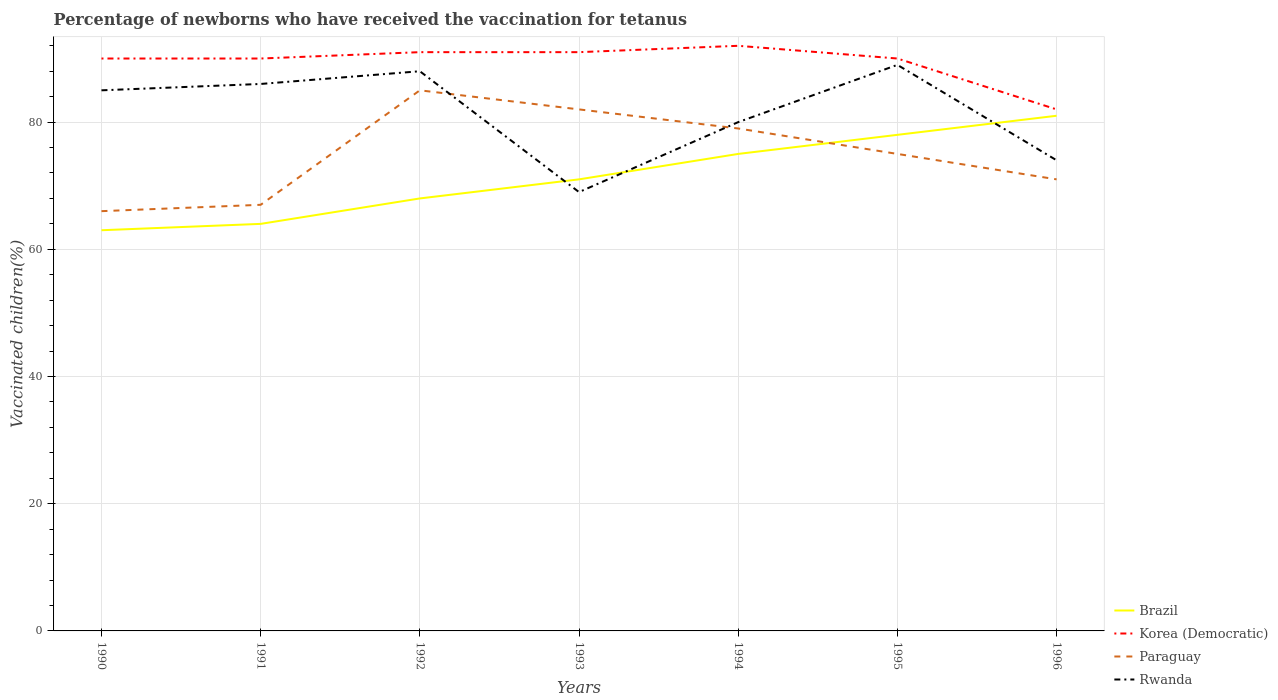Does the line corresponding to Paraguay intersect with the line corresponding to Rwanda?
Offer a very short reply. Yes. In which year was the percentage of vaccinated children in Korea (Democratic) maximum?
Keep it short and to the point. 1996. What is the difference between the highest and the lowest percentage of vaccinated children in Paraguay?
Keep it short and to the point. 3. Is the percentage of vaccinated children in Korea (Democratic) strictly greater than the percentage of vaccinated children in Brazil over the years?
Provide a short and direct response. No. Are the values on the major ticks of Y-axis written in scientific E-notation?
Offer a very short reply. No. Where does the legend appear in the graph?
Your answer should be compact. Bottom right. What is the title of the graph?
Keep it short and to the point. Percentage of newborns who have received the vaccination for tetanus. What is the label or title of the X-axis?
Make the answer very short. Years. What is the label or title of the Y-axis?
Offer a terse response. Vaccinated children(%). What is the Vaccinated children(%) of Korea (Democratic) in 1990?
Give a very brief answer. 90. What is the Vaccinated children(%) of Paraguay in 1990?
Keep it short and to the point. 66. What is the Vaccinated children(%) in Rwanda in 1990?
Keep it short and to the point. 85. What is the Vaccinated children(%) of Paraguay in 1991?
Offer a very short reply. 67. What is the Vaccinated children(%) in Korea (Democratic) in 1992?
Your answer should be very brief. 91. What is the Vaccinated children(%) in Rwanda in 1992?
Your answer should be compact. 88. What is the Vaccinated children(%) of Brazil in 1993?
Ensure brevity in your answer.  71. What is the Vaccinated children(%) of Korea (Democratic) in 1993?
Your answer should be compact. 91. What is the Vaccinated children(%) in Paraguay in 1993?
Offer a very short reply. 82. What is the Vaccinated children(%) in Korea (Democratic) in 1994?
Your answer should be compact. 92. What is the Vaccinated children(%) in Paraguay in 1994?
Your answer should be compact. 79. What is the Vaccinated children(%) in Brazil in 1995?
Your answer should be very brief. 78. What is the Vaccinated children(%) of Rwanda in 1995?
Provide a short and direct response. 89. What is the Vaccinated children(%) in Paraguay in 1996?
Your response must be concise. 71. What is the Vaccinated children(%) in Rwanda in 1996?
Offer a very short reply. 74. Across all years, what is the maximum Vaccinated children(%) of Brazil?
Offer a very short reply. 81. Across all years, what is the maximum Vaccinated children(%) in Korea (Democratic)?
Provide a succinct answer. 92. Across all years, what is the maximum Vaccinated children(%) of Rwanda?
Provide a short and direct response. 89. Across all years, what is the minimum Vaccinated children(%) in Brazil?
Keep it short and to the point. 63. Across all years, what is the minimum Vaccinated children(%) in Paraguay?
Give a very brief answer. 66. What is the total Vaccinated children(%) in Korea (Democratic) in the graph?
Give a very brief answer. 626. What is the total Vaccinated children(%) in Paraguay in the graph?
Your answer should be compact. 525. What is the total Vaccinated children(%) in Rwanda in the graph?
Ensure brevity in your answer.  571. What is the difference between the Vaccinated children(%) of Brazil in 1990 and that in 1991?
Offer a very short reply. -1. What is the difference between the Vaccinated children(%) in Paraguay in 1990 and that in 1992?
Provide a short and direct response. -19. What is the difference between the Vaccinated children(%) of Brazil in 1990 and that in 1993?
Ensure brevity in your answer.  -8. What is the difference between the Vaccinated children(%) in Paraguay in 1990 and that in 1993?
Offer a terse response. -16. What is the difference between the Vaccinated children(%) in Brazil in 1990 and that in 1994?
Make the answer very short. -12. What is the difference between the Vaccinated children(%) in Korea (Democratic) in 1990 and that in 1994?
Offer a terse response. -2. What is the difference between the Vaccinated children(%) in Rwanda in 1990 and that in 1994?
Offer a very short reply. 5. What is the difference between the Vaccinated children(%) in Brazil in 1990 and that in 1995?
Make the answer very short. -15. What is the difference between the Vaccinated children(%) in Paraguay in 1990 and that in 1995?
Offer a terse response. -9. What is the difference between the Vaccinated children(%) in Rwanda in 1990 and that in 1995?
Your answer should be compact. -4. What is the difference between the Vaccinated children(%) in Brazil in 1990 and that in 1996?
Ensure brevity in your answer.  -18. What is the difference between the Vaccinated children(%) of Korea (Democratic) in 1990 and that in 1996?
Provide a succinct answer. 8. What is the difference between the Vaccinated children(%) of Rwanda in 1990 and that in 1996?
Keep it short and to the point. 11. What is the difference between the Vaccinated children(%) in Brazil in 1991 and that in 1992?
Make the answer very short. -4. What is the difference between the Vaccinated children(%) in Brazil in 1991 and that in 1993?
Provide a short and direct response. -7. What is the difference between the Vaccinated children(%) in Brazil in 1991 and that in 1994?
Provide a short and direct response. -11. What is the difference between the Vaccinated children(%) in Korea (Democratic) in 1991 and that in 1994?
Ensure brevity in your answer.  -2. What is the difference between the Vaccinated children(%) in Paraguay in 1991 and that in 1995?
Your response must be concise. -8. What is the difference between the Vaccinated children(%) of Rwanda in 1991 and that in 1995?
Make the answer very short. -3. What is the difference between the Vaccinated children(%) of Korea (Democratic) in 1991 and that in 1996?
Give a very brief answer. 8. What is the difference between the Vaccinated children(%) of Korea (Democratic) in 1992 and that in 1993?
Provide a short and direct response. 0. What is the difference between the Vaccinated children(%) of Rwanda in 1992 and that in 1993?
Your answer should be compact. 19. What is the difference between the Vaccinated children(%) in Korea (Democratic) in 1992 and that in 1994?
Keep it short and to the point. -1. What is the difference between the Vaccinated children(%) of Paraguay in 1992 and that in 1994?
Provide a succinct answer. 6. What is the difference between the Vaccinated children(%) in Rwanda in 1992 and that in 1994?
Your answer should be compact. 8. What is the difference between the Vaccinated children(%) of Brazil in 1992 and that in 1995?
Your answer should be very brief. -10. What is the difference between the Vaccinated children(%) of Paraguay in 1992 and that in 1995?
Your answer should be compact. 10. What is the difference between the Vaccinated children(%) in Brazil in 1992 and that in 1996?
Give a very brief answer. -13. What is the difference between the Vaccinated children(%) of Korea (Democratic) in 1992 and that in 1996?
Give a very brief answer. 9. What is the difference between the Vaccinated children(%) of Brazil in 1993 and that in 1994?
Make the answer very short. -4. What is the difference between the Vaccinated children(%) in Paraguay in 1993 and that in 1994?
Give a very brief answer. 3. What is the difference between the Vaccinated children(%) of Rwanda in 1993 and that in 1994?
Provide a short and direct response. -11. What is the difference between the Vaccinated children(%) in Brazil in 1993 and that in 1995?
Provide a succinct answer. -7. What is the difference between the Vaccinated children(%) in Korea (Democratic) in 1993 and that in 1995?
Make the answer very short. 1. What is the difference between the Vaccinated children(%) in Korea (Democratic) in 1993 and that in 1996?
Provide a short and direct response. 9. What is the difference between the Vaccinated children(%) in Rwanda in 1993 and that in 1996?
Your answer should be compact. -5. What is the difference between the Vaccinated children(%) of Brazil in 1994 and that in 1995?
Provide a short and direct response. -3. What is the difference between the Vaccinated children(%) in Rwanda in 1994 and that in 1995?
Provide a short and direct response. -9. What is the difference between the Vaccinated children(%) of Korea (Democratic) in 1994 and that in 1996?
Your answer should be very brief. 10. What is the difference between the Vaccinated children(%) in Rwanda in 1994 and that in 1996?
Give a very brief answer. 6. What is the difference between the Vaccinated children(%) in Korea (Democratic) in 1995 and that in 1996?
Your answer should be compact. 8. What is the difference between the Vaccinated children(%) in Brazil in 1990 and the Vaccinated children(%) in Korea (Democratic) in 1991?
Your response must be concise. -27. What is the difference between the Vaccinated children(%) of Brazil in 1990 and the Vaccinated children(%) of Paraguay in 1991?
Offer a very short reply. -4. What is the difference between the Vaccinated children(%) in Brazil in 1990 and the Vaccinated children(%) in Rwanda in 1991?
Offer a terse response. -23. What is the difference between the Vaccinated children(%) in Brazil in 1990 and the Vaccinated children(%) in Korea (Democratic) in 1992?
Give a very brief answer. -28. What is the difference between the Vaccinated children(%) in Brazil in 1990 and the Vaccinated children(%) in Rwanda in 1992?
Give a very brief answer. -25. What is the difference between the Vaccinated children(%) of Korea (Democratic) in 1990 and the Vaccinated children(%) of Paraguay in 1992?
Offer a terse response. 5. What is the difference between the Vaccinated children(%) in Korea (Democratic) in 1990 and the Vaccinated children(%) in Rwanda in 1992?
Provide a short and direct response. 2. What is the difference between the Vaccinated children(%) in Paraguay in 1990 and the Vaccinated children(%) in Rwanda in 1992?
Your answer should be very brief. -22. What is the difference between the Vaccinated children(%) of Brazil in 1990 and the Vaccinated children(%) of Paraguay in 1993?
Provide a short and direct response. -19. What is the difference between the Vaccinated children(%) of Brazil in 1990 and the Vaccinated children(%) of Korea (Democratic) in 1994?
Ensure brevity in your answer.  -29. What is the difference between the Vaccinated children(%) of Korea (Democratic) in 1990 and the Vaccinated children(%) of Rwanda in 1994?
Your response must be concise. 10. What is the difference between the Vaccinated children(%) of Paraguay in 1990 and the Vaccinated children(%) of Rwanda in 1994?
Provide a short and direct response. -14. What is the difference between the Vaccinated children(%) in Brazil in 1990 and the Vaccinated children(%) in Paraguay in 1995?
Offer a terse response. -12. What is the difference between the Vaccinated children(%) of Brazil in 1990 and the Vaccinated children(%) of Rwanda in 1995?
Keep it short and to the point. -26. What is the difference between the Vaccinated children(%) in Korea (Democratic) in 1990 and the Vaccinated children(%) in Rwanda in 1995?
Offer a very short reply. 1. What is the difference between the Vaccinated children(%) in Brazil in 1990 and the Vaccinated children(%) in Korea (Democratic) in 1996?
Provide a short and direct response. -19. What is the difference between the Vaccinated children(%) of Brazil in 1990 and the Vaccinated children(%) of Paraguay in 1996?
Give a very brief answer. -8. What is the difference between the Vaccinated children(%) of Brazil in 1990 and the Vaccinated children(%) of Rwanda in 1996?
Provide a short and direct response. -11. What is the difference between the Vaccinated children(%) of Korea (Democratic) in 1990 and the Vaccinated children(%) of Rwanda in 1996?
Your response must be concise. 16. What is the difference between the Vaccinated children(%) in Paraguay in 1990 and the Vaccinated children(%) in Rwanda in 1996?
Provide a short and direct response. -8. What is the difference between the Vaccinated children(%) of Brazil in 1991 and the Vaccinated children(%) of Korea (Democratic) in 1992?
Offer a very short reply. -27. What is the difference between the Vaccinated children(%) of Brazil in 1991 and the Vaccinated children(%) of Paraguay in 1993?
Your answer should be very brief. -18. What is the difference between the Vaccinated children(%) in Korea (Democratic) in 1991 and the Vaccinated children(%) in Paraguay in 1993?
Offer a very short reply. 8. What is the difference between the Vaccinated children(%) in Korea (Democratic) in 1991 and the Vaccinated children(%) in Rwanda in 1993?
Offer a terse response. 21. What is the difference between the Vaccinated children(%) of Brazil in 1991 and the Vaccinated children(%) of Paraguay in 1994?
Give a very brief answer. -15. What is the difference between the Vaccinated children(%) of Brazil in 1991 and the Vaccinated children(%) of Rwanda in 1994?
Offer a terse response. -16. What is the difference between the Vaccinated children(%) in Paraguay in 1991 and the Vaccinated children(%) in Rwanda in 1994?
Keep it short and to the point. -13. What is the difference between the Vaccinated children(%) of Brazil in 1991 and the Vaccinated children(%) of Korea (Democratic) in 1995?
Give a very brief answer. -26. What is the difference between the Vaccinated children(%) in Brazil in 1991 and the Vaccinated children(%) in Paraguay in 1995?
Offer a very short reply. -11. What is the difference between the Vaccinated children(%) in Korea (Democratic) in 1991 and the Vaccinated children(%) in Paraguay in 1995?
Your answer should be compact. 15. What is the difference between the Vaccinated children(%) of Paraguay in 1991 and the Vaccinated children(%) of Rwanda in 1995?
Provide a short and direct response. -22. What is the difference between the Vaccinated children(%) of Brazil in 1991 and the Vaccinated children(%) of Korea (Democratic) in 1996?
Keep it short and to the point. -18. What is the difference between the Vaccinated children(%) in Brazil in 1991 and the Vaccinated children(%) in Paraguay in 1996?
Your answer should be compact. -7. What is the difference between the Vaccinated children(%) of Brazil in 1991 and the Vaccinated children(%) of Rwanda in 1996?
Your answer should be compact. -10. What is the difference between the Vaccinated children(%) in Korea (Democratic) in 1991 and the Vaccinated children(%) in Paraguay in 1996?
Keep it short and to the point. 19. What is the difference between the Vaccinated children(%) in Korea (Democratic) in 1991 and the Vaccinated children(%) in Rwanda in 1996?
Give a very brief answer. 16. What is the difference between the Vaccinated children(%) in Paraguay in 1991 and the Vaccinated children(%) in Rwanda in 1996?
Keep it short and to the point. -7. What is the difference between the Vaccinated children(%) in Brazil in 1992 and the Vaccinated children(%) in Korea (Democratic) in 1993?
Ensure brevity in your answer.  -23. What is the difference between the Vaccinated children(%) in Brazil in 1992 and the Vaccinated children(%) in Paraguay in 1993?
Provide a succinct answer. -14. What is the difference between the Vaccinated children(%) of Paraguay in 1992 and the Vaccinated children(%) of Rwanda in 1993?
Provide a succinct answer. 16. What is the difference between the Vaccinated children(%) in Brazil in 1992 and the Vaccinated children(%) in Paraguay in 1994?
Provide a short and direct response. -11. What is the difference between the Vaccinated children(%) of Korea (Democratic) in 1992 and the Vaccinated children(%) of Paraguay in 1994?
Offer a terse response. 12. What is the difference between the Vaccinated children(%) in Korea (Democratic) in 1992 and the Vaccinated children(%) in Rwanda in 1994?
Make the answer very short. 11. What is the difference between the Vaccinated children(%) of Brazil in 1992 and the Vaccinated children(%) of Korea (Democratic) in 1995?
Keep it short and to the point. -22. What is the difference between the Vaccinated children(%) in Korea (Democratic) in 1992 and the Vaccinated children(%) in Paraguay in 1995?
Keep it short and to the point. 16. What is the difference between the Vaccinated children(%) in Paraguay in 1992 and the Vaccinated children(%) in Rwanda in 1995?
Offer a very short reply. -4. What is the difference between the Vaccinated children(%) of Brazil in 1992 and the Vaccinated children(%) of Korea (Democratic) in 1996?
Offer a terse response. -14. What is the difference between the Vaccinated children(%) of Brazil in 1992 and the Vaccinated children(%) of Paraguay in 1996?
Keep it short and to the point. -3. What is the difference between the Vaccinated children(%) in Brazil in 1992 and the Vaccinated children(%) in Rwanda in 1996?
Offer a terse response. -6. What is the difference between the Vaccinated children(%) in Korea (Democratic) in 1992 and the Vaccinated children(%) in Rwanda in 1996?
Provide a succinct answer. 17. What is the difference between the Vaccinated children(%) of Paraguay in 1992 and the Vaccinated children(%) of Rwanda in 1996?
Your answer should be compact. 11. What is the difference between the Vaccinated children(%) of Brazil in 1993 and the Vaccinated children(%) of Korea (Democratic) in 1994?
Keep it short and to the point. -21. What is the difference between the Vaccinated children(%) in Brazil in 1993 and the Vaccinated children(%) in Paraguay in 1995?
Offer a very short reply. -4. What is the difference between the Vaccinated children(%) in Paraguay in 1993 and the Vaccinated children(%) in Rwanda in 1995?
Your answer should be very brief. -7. What is the difference between the Vaccinated children(%) in Brazil in 1993 and the Vaccinated children(%) in Korea (Democratic) in 1996?
Provide a succinct answer. -11. What is the difference between the Vaccinated children(%) in Korea (Democratic) in 1993 and the Vaccinated children(%) in Rwanda in 1996?
Provide a short and direct response. 17. What is the difference between the Vaccinated children(%) in Brazil in 1994 and the Vaccinated children(%) in Paraguay in 1995?
Offer a very short reply. 0. What is the difference between the Vaccinated children(%) in Korea (Democratic) in 1994 and the Vaccinated children(%) in Paraguay in 1995?
Keep it short and to the point. 17. What is the difference between the Vaccinated children(%) in Korea (Democratic) in 1994 and the Vaccinated children(%) in Rwanda in 1995?
Offer a terse response. 3. What is the difference between the Vaccinated children(%) in Paraguay in 1994 and the Vaccinated children(%) in Rwanda in 1995?
Provide a short and direct response. -10. What is the difference between the Vaccinated children(%) of Brazil in 1994 and the Vaccinated children(%) of Korea (Democratic) in 1996?
Make the answer very short. -7. What is the difference between the Vaccinated children(%) in Brazil in 1994 and the Vaccinated children(%) in Paraguay in 1996?
Provide a succinct answer. 4. What is the difference between the Vaccinated children(%) in Brazil in 1994 and the Vaccinated children(%) in Rwanda in 1996?
Offer a terse response. 1. What is the difference between the Vaccinated children(%) in Korea (Democratic) in 1995 and the Vaccinated children(%) in Paraguay in 1996?
Your answer should be very brief. 19. What is the difference between the Vaccinated children(%) in Korea (Democratic) in 1995 and the Vaccinated children(%) in Rwanda in 1996?
Your answer should be compact. 16. What is the average Vaccinated children(%) in Brazil per year?
Keep it short and to the point. 71.43. What is the average Vaccinated children(%) of Korea (Democratic) per year?
Keep it short and to the point. 89.43. What is the average Vaccinated children(%) of Paraguay per year?
Give a very brief answer. 75. What is the average Vaccinated children(%) in Rwanda per year?
Make the answer very short. 81.57. In the year 1990, what is the difference between the Vaccinated children(%) of Brazil and Vaccinated children(%) of Paraguay?
Your answer should be compact. -3. In the year 1990, what is the difference between the Vaccinated children(%) of Brazil and Vaccinated children(%) of Rwanda?
Your answer should be very brief. -22. In the year 1990, what is the difference between the Vaccinated children(%) in Korea (Democratic) and Vaccinated children(%) in Rwanda?
Offer a very short reply. 5. In the year 1991, what is the difference between the Vaccinated children(%) of Brazil and Vaccinated children(%) of Rwanda?
Ensure brevity in your answer.  -22. In the year 1991, what is the difference between the Vaccinated children(%) of Korea (Democratic) and Vaccinated children(%) of Rwanda?
Make the answer very short. 4. In the year 1992, what is the difference between the Vaccinated children(%) of Brazil and Vaccinated children(%) of Korea (Democratic)?
Your answer should be compact. -23. In the year 1992, what is the difference between the Vaccinated children(%) in Korea (Democratic) and Vaccinated children(%) in Paraguay?
Provide a succinct answer. 6. In the year 1992, what is the difference between the Vaccinated children(%) of Korea (Democratic) and Vaccinated children(%) of Rwanda?
Keep it short and to the point. 3. In the year 1993, what is the difference between the Vaccinated children(%) of Brazil and Vaccinated children(%) of Korea (Democratic)?
Your response must be concise. -20. In the year 1993, what is the difference between the Vaccinated children(%) of Brazil and Vaccinated children(%) of Paraguay?
Provide a succinct answer. -11. In the year 1993, what is the difference between the Vaccinated children(%) in Brazil and Vaccinated children(%) in Rwanda?
Your answer should be very brief. 2. In the year 1993, what is the difference between the Vaccinated children(%) in Korea (Democratic) and Vaccinated children(%) in Paraguay?
Offer a terse response. 9. In the year 1993, what is the difference between the Vaccinated children(%) of Paraguay and Vaccinated children(%) of Rwanda?
Offer a terse response. 13. In the year 1994, what is the difference between the Vaccinated children(%) of Brazil and Vaccinated children(%) of Korea (Democratic)?
Offer a very short reply. -17. In the year 1994, what is the difference between the Vaccinated children(%) of Brazil and Vaccinated children(%) of Rwanda?
Offer a very short reply. -5. In the year 1994, what is the difference between the Vaccinated children(%) of Korea (Democratic) and Vaccinated children(%) of Rwanda?
Ensure brevity in your answer.  12. In the year 1994, what is the difference between the Vaccinated children(%) of Paraguay and Vaccinated children(%) of Rwanda?
Give a very brief answer. -1. In the year 1995, what is the difference between the Vaccinated children(%) of Brazil and Vaccinated children(%) of Korea (Democratic)?
Your response must be concise. -12. In the year 1995, what is the difference between the Vaccinated children(%) in Brazil and Vaccinated children(%) in Rwanda?
Offer a terse response. -11. In the year 1995, what is the difference between the Vaccinated children(%) in Korea (Democratic) and Vaccinated children(%) in Rwanda?
Offer a very short reply. 1. In the year 1995, what is the difference between the Vaccinated children(%) of Paraguay and Vaccinated children(%) of Rwanda?
Ensure brevity in your answer.  -14. In the year 1996, what is the difference between the Vaccinated children(%) of Brazil and Vaccinated children(%) of Korea (Democratic)?
Offer a terse response. -1. In the year 1996, what is the difference between the Vaccinated children(%) in Brazil and Vaccinated children(%) in Rwanda?
Provide a succinct answer. 7. In the year 1996, what is the difference between the Vaccinated children(%) of Korea (Democratic) and Vaccinated children(%) of Paraguay?
Your answer should be very brief. 11. In the year 1996, what is the difference between the Vaccinated children(%) in Korea (Democratic) and Vaccinated children(%) in Rwanda?
Offer a terse response. 8. In the year 1996, what is the difference between the Vaccinated children(%) in Paraguay and Vaccinated children(%) in Rwanda?
Give a very brief answer. -3. What is the ratio of the Vaccinated children(%) in Brazil in 1990 to that in 1991?
Your response must be concise. 0.98. What is the ratio of the Vaccinated children(%) in Korea (Democratic) in 1990 to that in 1991?
Your answer should be compact. 1. What is the ratio of the Vaccinated children(%) in Paraguay in 1990 to that in 1991?
Offer a very short reply. 0.99. What is the ratio of the Vaccinated children(%) in Rwanda in 1990 to that in 1991?
Your response must be concise. 0.99. What is the ratio of the Vaccinated children(%) in Brazil in 1990 to that in 1992?
Your answer should be very brief. 0.93. What is the ratio of the Vaccinated children(%) of Paraguay in 1990 to that in 1992?
Your response must be concise. 0.78. What is the ratio of the Vaccinated children(%) of Rwanda in 1990 to that in 1992?
Ensure brevity in your answer.  0.97. What is the ratio of the Vaccinated children(%) in Brazil in 1990 to that in 1993?
Your response must be concise. 0.89. What is the ratio of the Vaccinated children(%) in Paraguay in 1990 to that in 1993?
Ensure brevity in your answer.  0.8. What is the ratio of the Vaccinated children(%) of Rwanda in 1990 to that in 1993?
Give a very brief answer. 1.23. What is the ratio of the Vaccinated children(%) in Brazil in 1990 to that in 1994?
Ensure brevity in your answer.  0.84. What is the ratio of the Vaccinated children(%) in Korea (Democratic) in 1990 to that in 1994?
Provide a short and direct response. 0.98. What is the ratio of the Vaccinated children(%) in Paraguay in 1990 to that in 1994?
Keep it short and to the point. 0.84. What is the ratio of the Vaccinated children(%) of Rwanda in 1990 to that in 1994?
Ensure brevity in your answer.  1.06. What is the ratio of the Vaccinated children(%) in Brazil in 1990 to that in 1995?
Provide a succinct answer. 0.81. What is the ratio of the Vaccinated children(%) in Rwanda in 1990 to that in 1995?
Your answer should be very brief. 0.96. What is the ratio of the Vaccinated children(%) in Brazil in 1990 to that in 1996?
Give a very brief answer. 0.78. What is the ratio of the Vaccinated children(%) in Korea (Democratic) in 1990 to that in 1996?
Make the answer very short. 1.1. What is the ratio of the Vaccinated children(%) in Paraguay in 1990 to that in 1996?
Offer a terse response. 0.93. What is the ratio of the Vaccinated children(%) of Rwanda in 1990 to that in 1996?
Offer a very short reply. 1.15. What is the ratio of the Vaccinated children(%) of Korea (Democratic) in 1991 to that in 1992?
Provide a short and direct response. 0.99. What is the ratio of the Vaccinated children(%) of Paraguay in 1991 to that in 1992?
Provide a succinct answer. 0.79. What is the ratio of the Vaccinated children(%) in Rwanda in 1991 to that in 1992?
Your answer should be very brief. 0.98. What is the ratio of the Vaccinated children(%) in Brazil in 1991 to that in 1993?
Provide a succinct answer. 0.9. What is the ratio of the Vaccinated children(%) of Korea (Democratic) in 1991 to that in 1993?
Ensure brevity in your answer.  0.99. What is the ratio of the Vaccinated children(%) of Paraguay in 1991 to that in 1993?
Provide a short and direct response. 0.82. What is the ratio of the Vaccinated children(%) of Rwanda in 1991 to that in 1993?
Keep it short and to the point. 1.25. What is the ratio of the Vaccinated children(%) of Brazil in 1991 to that in 1994?
Keep it short and to the point. 0.85. What is the ratio of the Vaccinated children(%) of Korea (Democratic) in 1991 to that in 1994?
Provide a short and direct response. 0.98. What is the ratio of the Vaccinated children(%) in Paraguay in 1991 to that in 1994?
Your answer should be very brief. 0.85. What is the ratio of the Vaccinated children(%) in Rwanda in 1991 to that in 1994?
Give a very brief answer. 1.07. What is the ratio of the Vaccinated children(%) of Brazil in 1991 to that in 1995?
Offer a terse response. 0.82. What is the ratio of the Vaccinated children(%) of Korea (Democratic) in 1991 to that in 1995?
Make the answer very short. 1. What is the ratio of the Vaccinated children(%) of Paraguay in 1991 to that in 1995?
Give a very brief answer. 0.89. What is the ratio of the Vaccinated children(%) of Rwanda in 1991 to that in 1995?
Your answer should be compact. 0.97. What is the ratio of the Vaccinated children(%) of Brazil in 1991 to that in 1996?
Give a very brief answer. 0.79. What is the ratio of the Vaccinated children(%) of Korea (Democratic) in 1991 to that in 1996?
Give a very brief answer. 1.1. What is the ratio of the Vaccinated children(%) in Paraguay in 1991 to that in 1996?
Your response must be concise. 0.94. What is the ratio of the Vaccinated children(%) of Rwanda in 1991 to that in 1996?
Give a very brief answer. 1.16. What is the ratio of the Vaccinated children(%) of Brazil in 1992 to that in 1993?
Provide a short and direct response. 0.96. What is the ratio of the Vaccinated children(%) in Korea (Democratic) in 1992 to that in 1993?
Keep it short and to the point. 1. What is the ratio of the Vaccinated children(%) of Paraguay in 1992 to that in 1993?
Give a very brief answer. 1.04. What is the ratio of the Vaccinated children(%) in Rwanda in 1992 to that in 1993?
Provide a short and direct response. 1.28. What is the ratio of the Vaccinated children(%) of Brazil in 1992 to that in 1994?
Your response must be concise. 0.91. What is the ratio of the Vaccinated children(%) of Korea (Democratic) in 1992 to that in 1994?
Your answer should be compact. 0.99. What is the ratio of the Vaccinated children(%) of Paraguay in 1992 to that in 1994?
Keep it short and to the point. 1.08. What is the ratio of the Vaccinated children(%) of Brazil in 1992 to that in 1995?
Keep it short and to the point. 0.87. What is the ratio of the Vaccinated children(%) in Korea (Democratic) in 1992 to that in 1995?
Offer a very short reply. 1.01. What is the ratio of the Vaccinated children(%) in Paraguay in 1992 to that in 1995?
Your answer should be very brief. 1.13. What is the ratio of the Vaccinated children(%) of Rwanda in 1992 to that in 1995?
Keep it short and to the point. 0.99. What is the ratio of the Vaccinated children(%) of Brazil in 1992 to that in 1996?
Give a very brief answer. 0.84. What is the ratio of the Vaccinated children(%) of Korea (Democratic) in 1992 to that in 1996?
Your answer should be very brief. 1.11. What is the ratio of the Vaccinated children(%) in Paraguay in 1992 to that in 1996?
Ensure brevity in your answer.  1.2. What is the ratio of the Vaccinated children(%) in Rwanda in 1992 to that in 1996?
Provide a succinct answer. 1.19. What is the ratio of the Vaccinated children(%) in Brazil in 1993 to that in 1994?
Provide a succinct answer. 0.95. What is the ratio of the Vaccinated children(%) of Korea (Democratic) in 1993 to that in 1994?
Provide a short and direct response. 0.99. What is the ratio of the Vaccinated children(%) of Paraguay in 1993 to that in 1994?
Give a very brief answer. 1.04. What is the ratio of the Vaccinated children(%) in Rwanda in 1993 to that in 1994?
Make the answer very short. 0.86. What is the ratio of the Vaccinated children(%) in Brazil in 1993 to that in 1995?
Offer a very short reply. 0.91. What is the ratio of the Vaccinated children(%) of Korea (Democratic) in 1993 to that in 1995?
Give a very brief answer. 1.01. What is the ratio of the Vaccinated children(%) in Paraguay in 1993 to that in 1995?
Make the answer very short. 1.09. What is the ratio of the Vaccinated children(%) of Rwanda in 1993 to that in 1995?
Offer a terse response. 0.78. What is the ratio of the Vaccinated children(%) in Brazil in 1993 to that in 1996?
Offer a very short reply. 0.88. What is the ratio of the Vaccinated children(%) of Korea (Democratic) in 1993 to that in 1996?
Your answer should be very brief. 1.11. What is the ratio of the Vaccinated children(%) in Paraguay in 1993 to that in 1996?
Provide a succinct answer. 1.15. What is the ratio of the Vaccinated children(%) of Rwanda in 1993 to that in 1996?
Provide a short and direct response. 0.93. What is the ratio of the Vaccinated children(%) of Brazil in 1994 to that in 1995?
Provide a short and direct response. 0.96. What is the ratio of the Vaccinated children(%) in Korea (Democratic) in 1994 to that in 1995?
Make the answer very short. 1.02. What is the ratio of the Vaccinated children(%) in Paraguay in 1994 to that in 1995?
Offer a very short reply. 1.05. What is the ratio of the Vaccinated children(%) in Rwanda in 1994 to that in 1995?
Provide a short and direct response. 0.9. What is the ratio of the Vaccinated children(%) of Brazil in 1994 to that in 1996?
Your answer should be very brief. 0.93. What is the ratio of the Vaccinated children(%) in Korea (Democratic) in 1994 to that in 1996?
Provide a short and direct response. 1.12. What is the ratio of the Vaccinated children(%) of Paraguay in 1994 to that in 1996?
Offer a very short reply. 1.11. What is the ratio of the Vaccinated children(%) of Rwanda in 1994 to that in 1996?
Provide a succinct answer. 1.08. What is the ratio of the Vaccinated children(%) in Korea (Democratic) in 1995 to that in 1996?
Provide a succinct answer. 1.1. What is the ratio of the Vaccinated children(%) of Paraguay in 1995 to that in 1996?
Provide a succinct answer. 1.06. What is the ratio of the Vaccinated children(%) of Rwanda in 1995 to that in 1996?
Offer a terse response. 1.2. What is the difference between the highest and the second highest Vaccinated children(%) in Brazil?
Make the answer very short. 3. What is the difference between the highest and the second highest Vaccinated children(%) of Paraguay?
Make the answer very short. 3. What is the difference between the highest and the lowest Vaccinated children(%) of Brazil?
Provide a short and direct response. 18. What is the difference between the highest and the lowest Vaccinated children(%) of Korea (Democratic)?
Give a very brief answer. 10. What is the difference between the highest and the lowest Vaccinated children(%) of Paraguay?
Keep it short and to the point. 19. What is the difference between the highest and the lowest Vaccinated children(%) of Rwanda?
Offer a terse response. 20. 